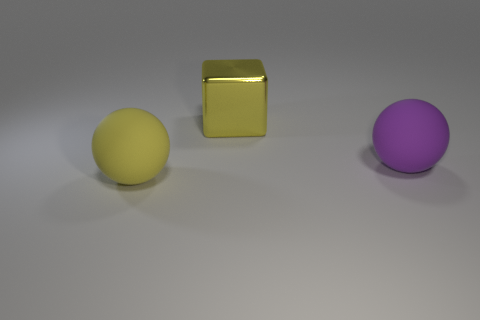Add 2 small purple blocks. How many objects exist? 5 Subtract all cubes. How many objects are left? 2 Subtract all big yellow rubber spheres. Subtract all small gray matte cubes. How many objects are left? 2 Add 1 big purple balls. How many big purple balls are left? 2 Add 1 small gray matte cylinders. How many small gray matte cylinders exist? 1 Subtract 0 brown cylinders. How many objects are left? 3 